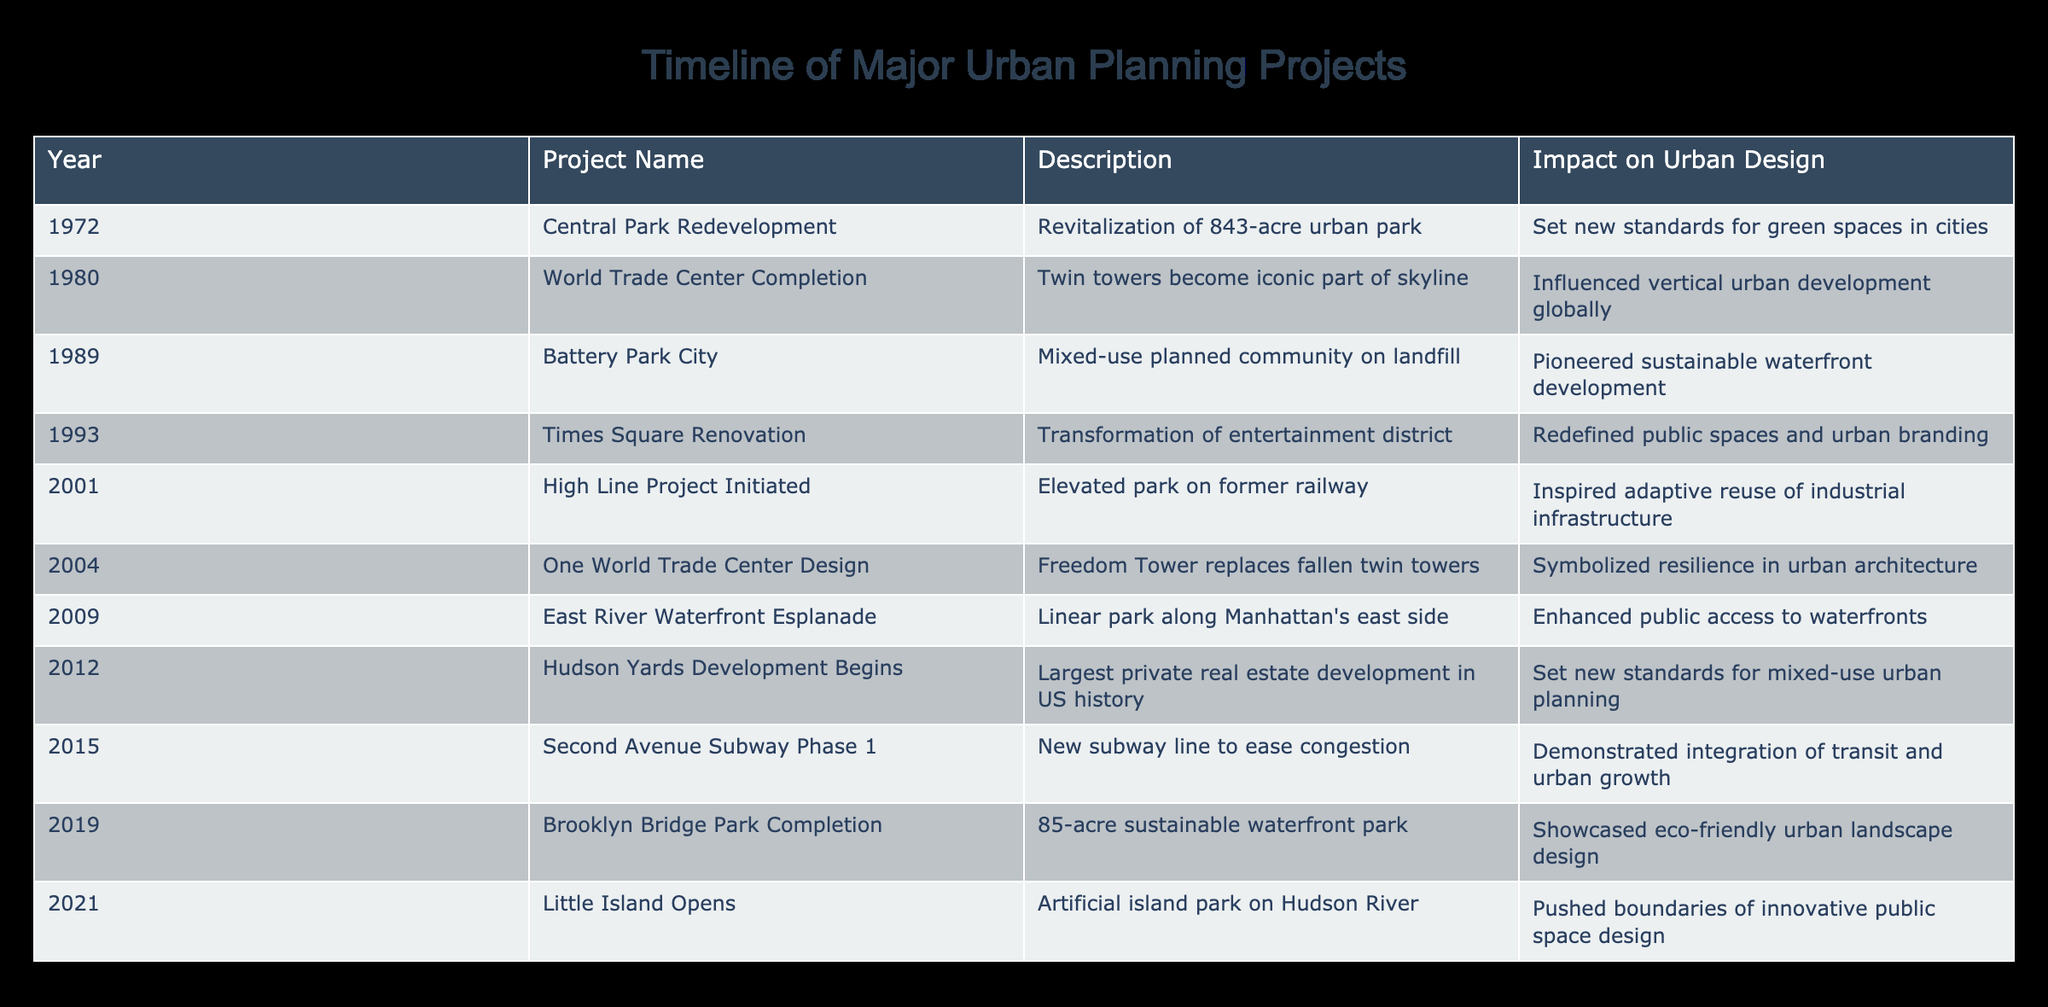What year did the Central Park Redevelopment project take place? The table lists the Central Park Redevelopment project under the year 1972, with no other references contradicting this year. Thus, the project occurred in 1972.
Answer: 1972 Which project marked the beginning of the High Line Project? The table indicates that the High Line Project was initiated in 2001, which is the only listed year for this project. Therefore, 2001 marks the start of the High Line Project.
Answer: 2001 How many years passed between the completion of the World Trade Center and the Times Square Renovation? The World Trade Center was completed in 1980, and the Times Square Renovation occurred in 1993. Calculating the difference: 1993 - 1980 = 13 years. Thus, 13 years elapsed between these two projects.
Answer: 13 Did the Battery Park City project prioritize sustainable waterfront development? According to the table, the description of Battery Park City states that it was a mixed-use community built on landfill and specifically mentions pioneering sustainable waterfront development. This confirms that it did prioritize sustainability.
Answer: Yes Which project is the largest private real estate development in US history according to the table? The table clearly states that the Hudson Yards Development, which began in 2012, is the largest private real estate development in US history. Hence, this project holds that title.
Answer: Hudson Yards Development What was the impact of the Times Square Renovation on urban branding? The Times Square Renovation's impact is described as having redefined public spaces and urban branding. This indicates that the project significantly influenced how urban spaces are perceived and branded.
Answer: Redefined public spaces and urban branding Which years saw projects that focused primarily on enhancing public spaces? The projects enhancing public spaces are the Central Park Redevelopment (1972), Times Square Renovation (1993), East River Waterfront Esplanade (2009), and Little Island (2021). Summing these years, we identify four distinct projects focused on public space enhancement.
Answer: 1972, 1993, 2009, 2021 What is the average year of the projects listed in the table? The years of all projects referenced are: 1972, 1980, 1989, 1993, 2001, 2004, 2009, 2012, 2015, 2019, and 2021, totaling 11 years. The sum is 21,860, so the average year is calculated: 21,860 / 11 ≈ 1986.36. Thus, the average year of the projects is approximately 1986.
Answer: 1986 